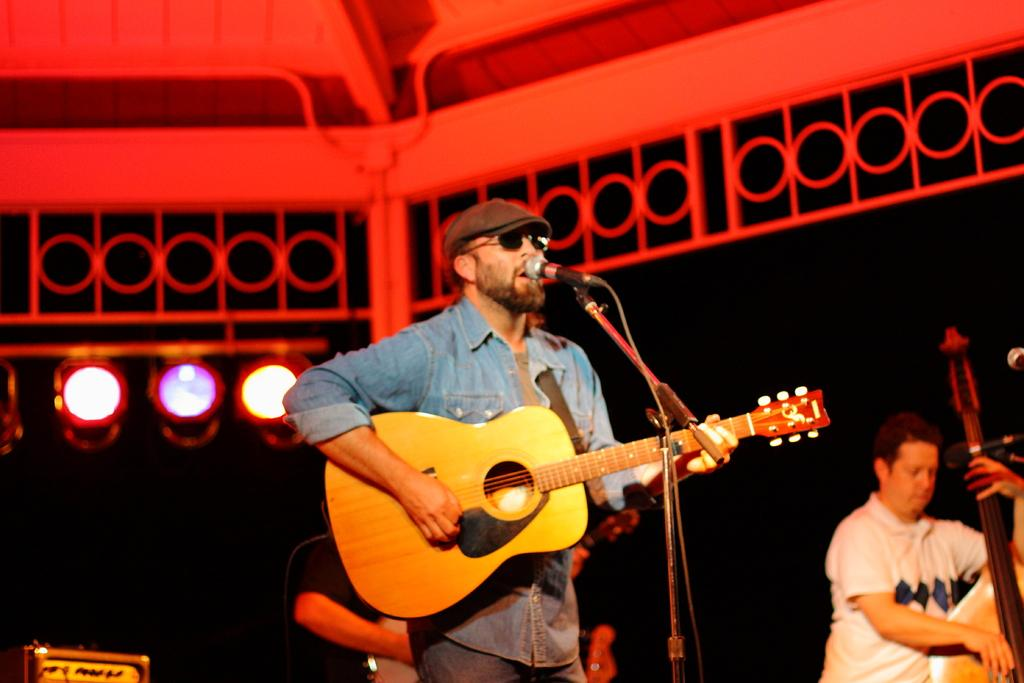What is the person in the image doing? The person is standing, holding a guitar, and singing. What is the person wearing on their head? The person is wearing a cap. What is the person holding in addition to the guitar? The person is holding a musical instrument, which is a guitar. What can be seen in the background of the image? There are focusing lights in the background. What equipment is present for amplifying the person's voice? There is a microphone with a stand in the image. What type of stocking is the person wearing on their leg in the image? There is no mention of stockings in the image, so it cannot be determined if the person is wearing any. What punishment is the person receiving for playing the guitar in the image? There is no indication of any punishment in the image; the person is playing the guitar and singing. 